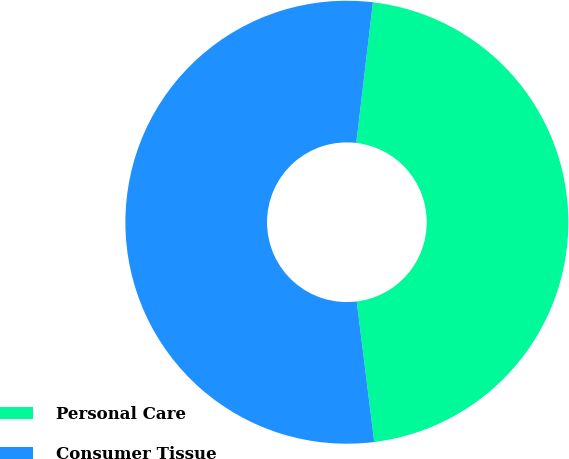Convert chart to OTSL. <chart><loc_0><loc_0><loc_500><loc_500><pie_chart><fcel>Personal Care<fcel>Consumer Tissue<nl><fcel>46.15%<fcel>53.85%<nl></chart> 